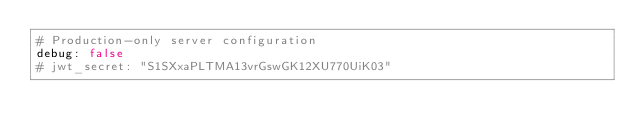<code> <loc_0><loc_0><loc_500><loc_500><_YAML_># Production-only server configuration
debug: false
# jwt_secret: "S1SXxaPLTMA13vrGswGK12XU770UiK03"</code> 